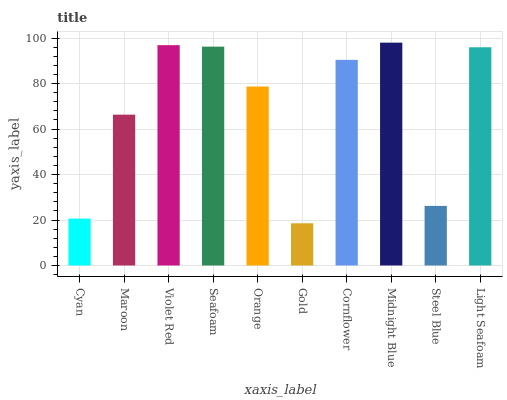Is Gold the minimum?
Answer yes or no. Yes. Is Midnight Blue the maximum?
Answer yes or no. Yes. Is Maroon the minimum?
Answer yes or no. No. Is Maroon the maximum?
Answer yes or no. No. Is Maroon greater than Cyan?
Answer yes or no. Yes. Is Cyan less than Maroon?
Answer yes or no. Yes. Is Cyan greater than Maroon?
Answer yes or no. No. Is Maroon less than Cyan?
Answer yes or no. No. Is Cornflower the high median?
Answer yes or no. Yes. Is Orange the low median?
Answer yes or no. Yes. Is Violet Red the high median?
Answer yes or no. No. Is Violet Red the low median?
Answer yes or no. No. 